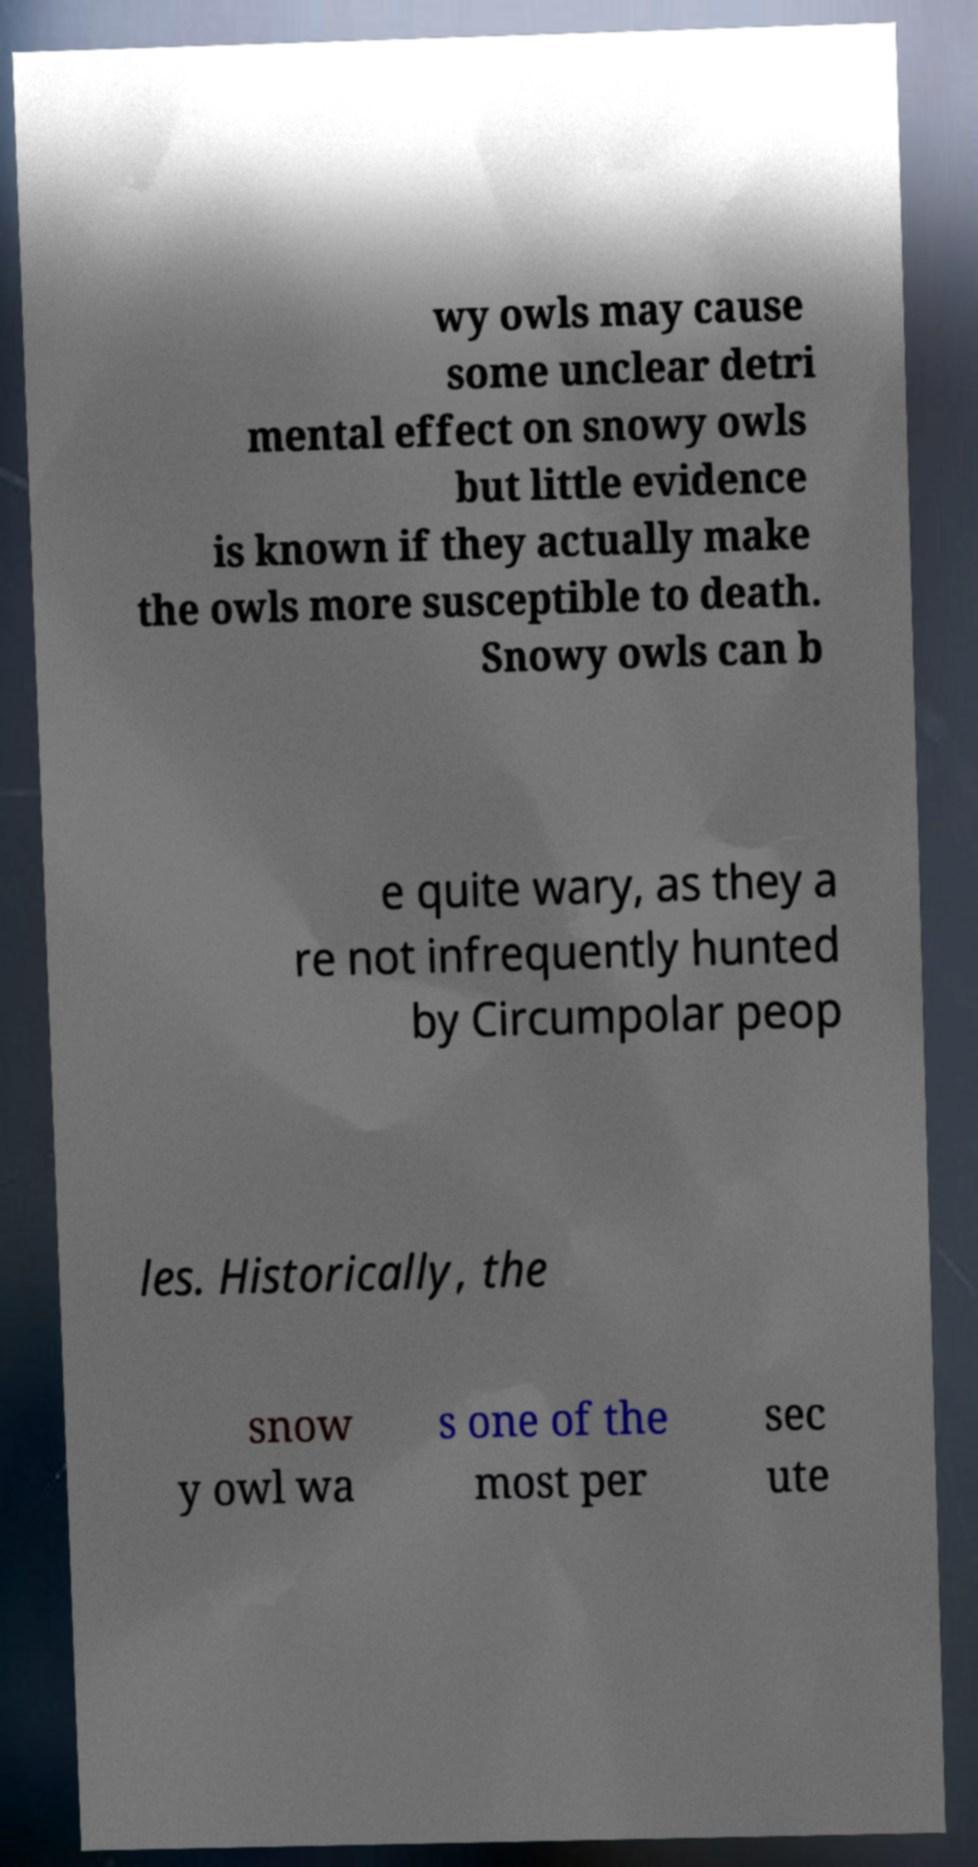Can you accurately transcribe the text from the provided image for me? wy owls may cause some unclear detri mental effect on snowy owls but little evidence is known if they actually make the owls more susceptible to death. Snowy owls can b e quite wary, as they a re not infrequently hunted by Circumpolar peop les. Historically, the snow y owl wa s one of the most per sec ute 